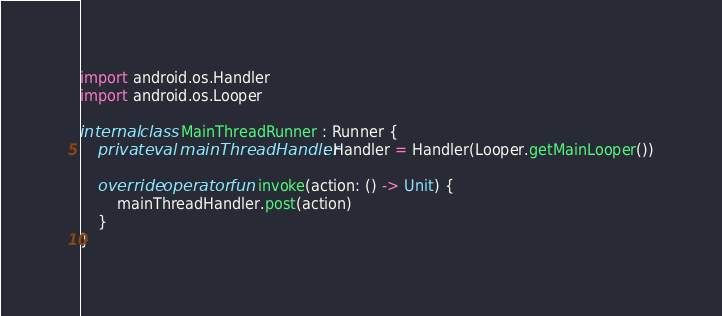<code> <loc_0><loc_0><loc_500><loc_500><_Kotlin_>
import android.os.Handler
import android.os.Looper

internal class MainThreadRunner : Runner {
    private val mainThreadHandler: Handler = Handler(Looper.getMainLooper())

    override operator fun invoke(action: () -> Unit) {
        mainThreadHandler.post(action)
    }
}
</code> 